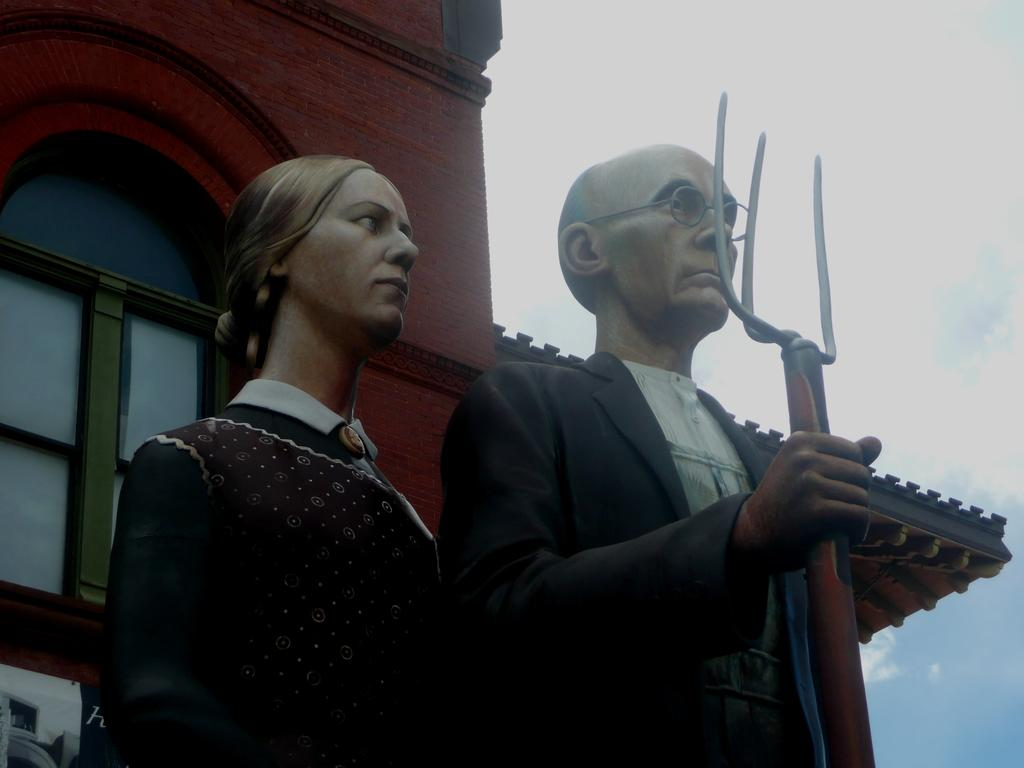What type of objects can be seen in the image? There are statues in the image. What structure is visible in the image? There is a building in the image. What part of the natural environment is visible in the image? The sky is visible in the image. What can be seen in the sky? Clouds are present in the sky. What type of grip can be seen on the statues in the image? There is no mention of a grip on the statues in the image, as they are likely made of a solid material. 